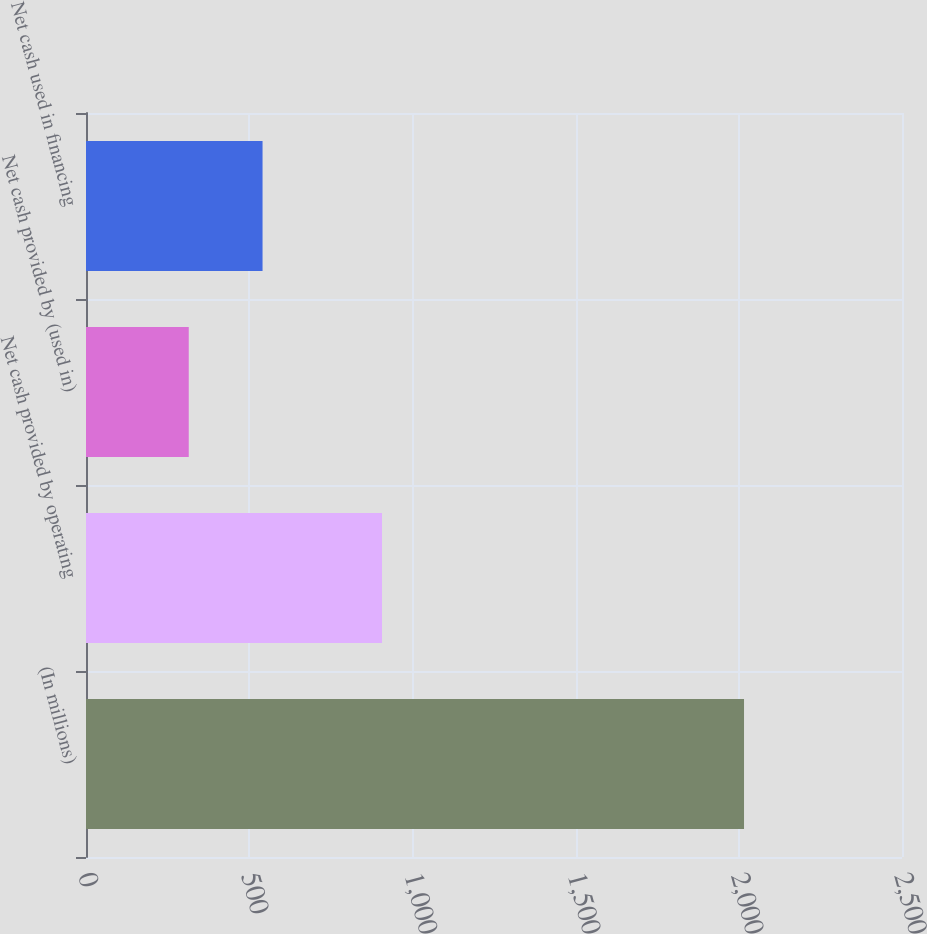Convert chart to OTSL. <chart><loc_0><loc_0><loc_500><loc_500><bar_chart><fcel>(In millions)<fcel>Net cash provided by operating<fcel>Net cash provided by (used in)<fcel>Net cash used in financing<nl><fcel>2016<fcel>906.9<fcel>314.8<fcel>540.9<nl></chart> 